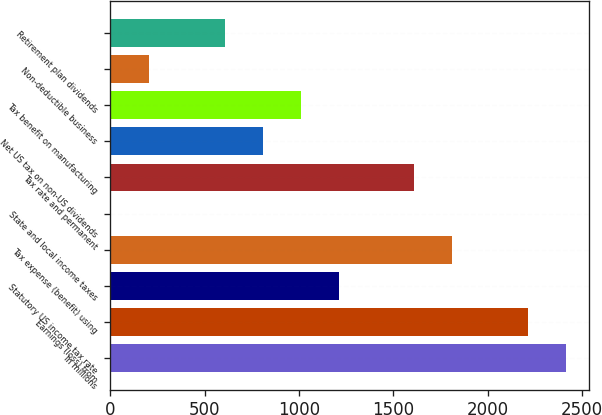<chart> <loc_0><loc_0><loc_500><loc_500><bar_chart><fcel>In millions<fcel>Earnings (loss) from<fcel>Statutory US income tax rate<fcel>Tax expense (benefit) using<fcel>State and local income taxes<fcel>Tax rate and permanent<fcel>Net US tax on non-US dividends<fcel>Tax benefit on manufacturing<fcel>Non-deductible business<fcel>Retirement plan dividends<nl><fcel>2414.8<fcel>2213.9<fcel>1209.4<fcel>1812.1<fcel>4<fcel>1611.2<fcel>807.6<fcel>1008.5<fcel>204.9<fcel>606.7<nl></chart> 